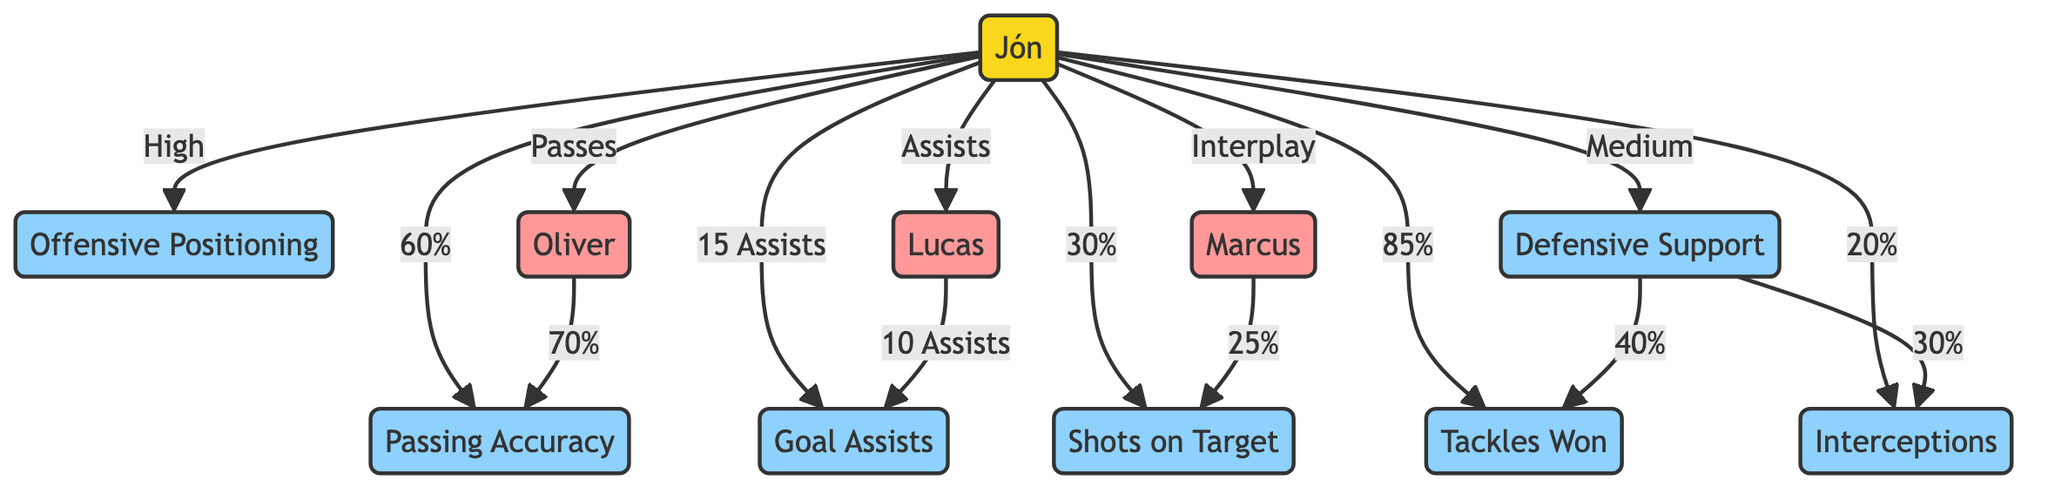What is Jón's Passing Accuracy? The diagram indicates that Jón's Passing Accuracy is represented by the edge connecting Jón to the Passing Accuracy node, which shows a value of "60%."
Answer: 60% How many Assists does Jón have? In the diagram, the edge between Jón and the Goal Assists node states "15 Assists," indicating the total number of assists made by Jón in matches.
Answer: 15 Assists What is the value of Shots on Target for Marcus? Marcus is connected to the Shots on Target node, which has a value of "25%," indicating this is the percentage of successful shots on target attributed to him.
Answer: 25% Which teammate has a Passing Accuracy of 70%? The edge connecting Oliver to the Passing Accuracy node specifies "70%," making it clear that Oliver has this Passing Accuracy.
Answer: Oliver What label describes Jón's Defensive Support? The edge from Jón to the Defensive Support node indicates a "Medium" level, which describes Jón's involvement in defensive support during matches.
Answer: Medium How does Jón interact with Lucas? The diagram displays an edge from Jón to Lucas with a label "Assists," indicating that Jón's interaction with Lucas is related to assisting him.
Answer: Assists Which teammate of Jón has the highest Tackles Won percentage? The diagram shows the connection from Defensive Support to Tackles Won, with a "40%" label. Since this is not a direct comparison, we focus on the edges indicating a percentage for other players. Given only the data provided, it's not possible to determine which player has the highest specific percentage mentioned in the context. However, as per the diagram, the highest percentage strictly based on the edge connected to Jón remains "85%" for Tackles Won attributed to him.
Answer: None What is the relationship between Jón and Marcus in terms of Interplay? The diagram indicates an edge between Jón and Marcus labeled "Interplay," referring to their collaborative playing style on the field.
Answer: Interplay How many metrics are directly linked to Jón? By counting the edges directly connected to Jón, we see that there are 8 distinct connections to different metrics, including Passing Accuracy, Goal Assists, Shots on Target, Offensive Positioning, Defensive Support, Tackles Won, Interceptions, and three teammates.
Answer: 8 